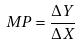Convert formula to latex. <formula><loc_0><loc_0><loc_500><loc_500>M P = \frac { \Delta Y } { \Delta X }</formula> 